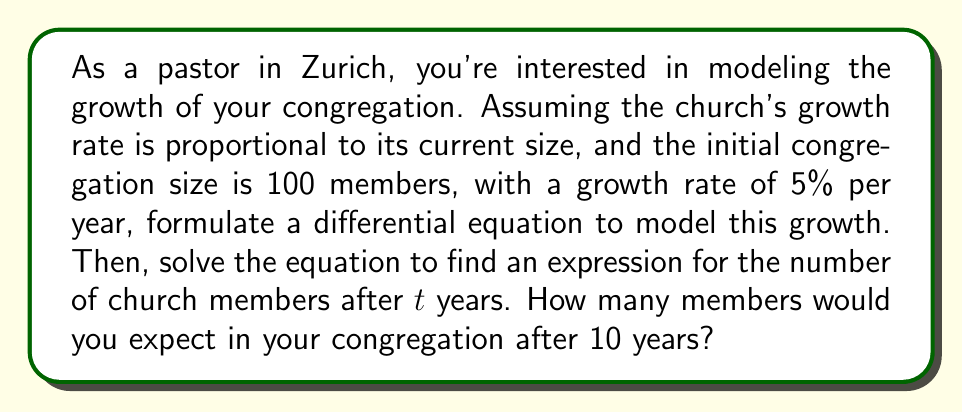Solve this math problem. Let's approach this step-by-step:

1) Let $N(t)$ be the number of church members at time $t$ (in years).

2) The growth rate is proportional to the current size, which can be expressed as:

   $$\frac{dN}{dt} = kN$$

   where $k$ is the growth rate constant.

3) We're given that the growth rate is 5% per year, so $k = 0.05$.

4) Our differential equation becomes:

   $$\frac{dN}{dt} = 0.05N$$

5) This is a separable differential equation. We can solve it as follows:

   $$\frac{dN}{N} = 0.05dt$$

6) Integrating both sides:

   $$\int \frac{dN}{N} = \int 0.05dt$$
   
   $$\ln|N| = 0.05t + C$$

7) Taking the exponential of both sides:

   $$N = e^{0.05t + C} = e^C \cdot e^{0.05t}$$

8) Let $A = e^C$. Then our general solution is:

   $$N(t) = Ae^{0.05t}$$

9) We can find $A$ using the initial condition: $N(0) = 100$

   $$100 = Ae^{0.05 \cdot 0} = A$$

10) Therefore, our particular solution is:

    $$N(t) = 100e^{0.05t}$$

11) To find the number of members after 10 years, we substitute $t = 10$:

    $$N(10) = 100e^{0.05 \cdot 10} = 100e^{0.5} \approx 164.87$$
Answer: The number of church members after 10 years would be approximately 165 members (rounded to the nearest whole number). 